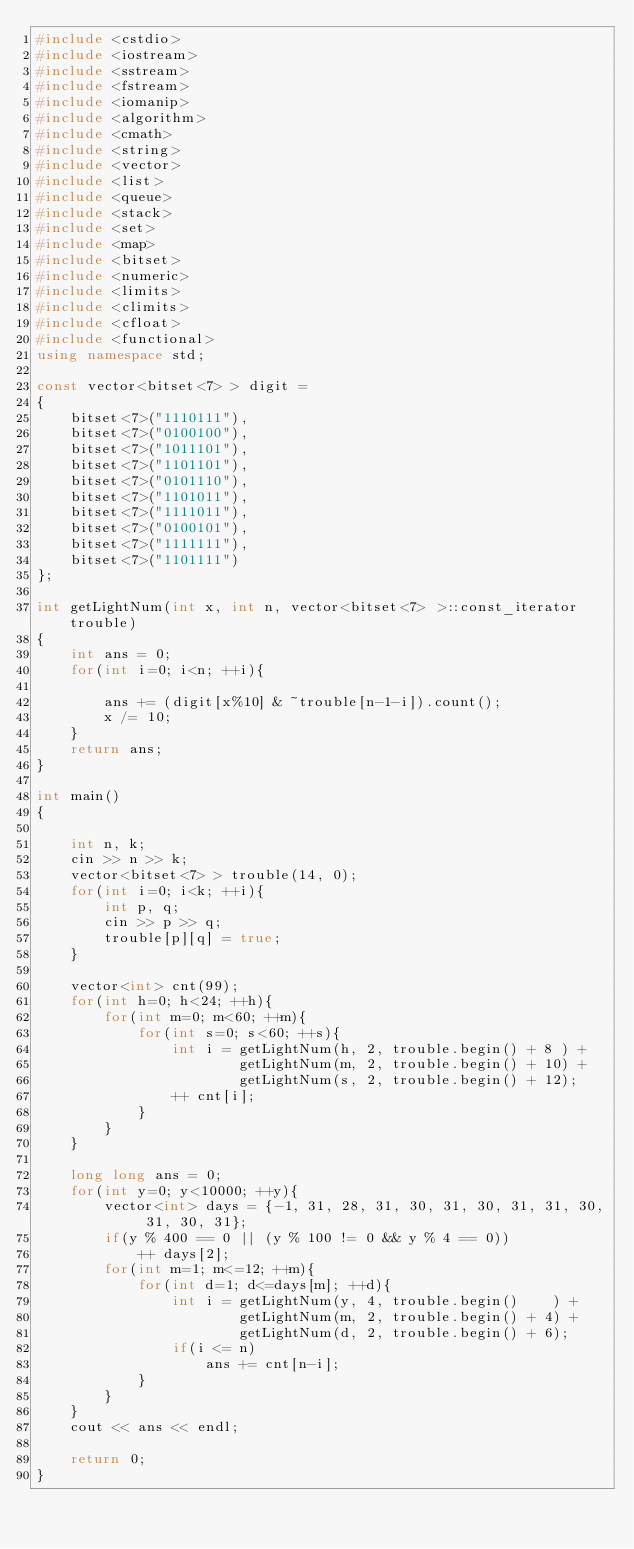Convert code to text. <code><loc_0><loc_0><loc_500><loc_500><_C++_>#include <cstdio>
#include <iostream>
#include <sstream>
#include <fstream>
#include <iomanip>
#include <algorithm>
#include <cmath>
#include <string>
#include <vector>
#include <list>
#include <queue>
#include <stack>
#include <set>
#include <map>
#include <bitset>
#include <numeric>
#include <limits>
#include <climits>
#include <cfloat>
#include <functional>
using namespace std;

const vector<bitset<7> > digit =
{
    bitset<7>("1110111"),
    bitset<7>("0100100"),
    bitset<7>("1011101"),
    bitset<7>("1101101"),
    bitset<7>("0101110"),
    bitset<7>("1101011"),
    bitset<7>("1111011"),
    bitset<7>("0100101"),
    bitset<7>("1111111"),
    bitset<7>("1101111")
};

int getLightNum(int x, int n, vector<bitset<7> >::const_iterator trouble)
{
    int ans = 0;
    for(int i=0; i<n; ++i){

        ans += (digit[x%10] & ~trouble[n-1-i]).count();
        x /= 10;
    }
    return ans;
}

int main()
{

    int n, k;
    cin >> n >> k;
    vector<bitset<7> > trouble(14, 0);
    for(int i=0; i<k; ++i){
        int p, q;
        cin >> p >> q;
        trouble[p][q] = true;
    }

    vector<int> cnt(99);
    for(int h=0; h<24; ++h){
        for(int m=0; m<60; ++m){
            for(int s=0; s<60; ++s){
                int i = getLightNum(h, 2, trouble.begin() + 8 ) +
                        getLightNum(m, 2, trouble.begin() + 10) +
                        getLightNum(s, 2, trouble.begin() + 12);
                ++ cnt[i];
            }
        }
    }

    long long ans = 0;
    for(int y=0; y<10000; ++y){
        vector<int> days = {-1, 31, 28, 31, 30, 31, 30, 31, 31, 30, 31, 30, 31};
        if(y % 400 == 0 || (y % 100 != 0 && y % 4 == 0))
            ++ days[2];
        for(int m=1; m<=12; ++m){
            for(int d=1; d<=days[m]; ++d){
                int i = getLightNum(y, 4, trouble.begin()    ) + 
                        getLightNum(m, 2, trouble.begin() + 4) +
                        getLightNum(d, 2, trouble.begin() + 6);
                if(i <= n)
                    ans += cnt[n-i];
            }
        }
    }
    cout << ans << endl;

    return 0;
}</code> 